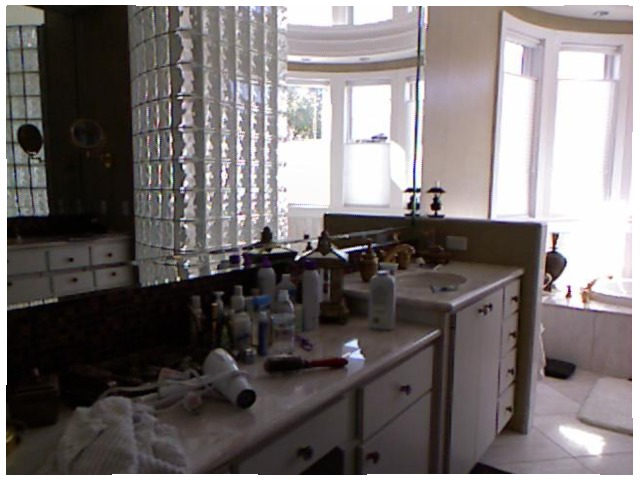<image>
Is there a cupboard under the bottle? Yes. The cupboard is positioned underneath the bottle, with the bottle above it in the vertical space. 